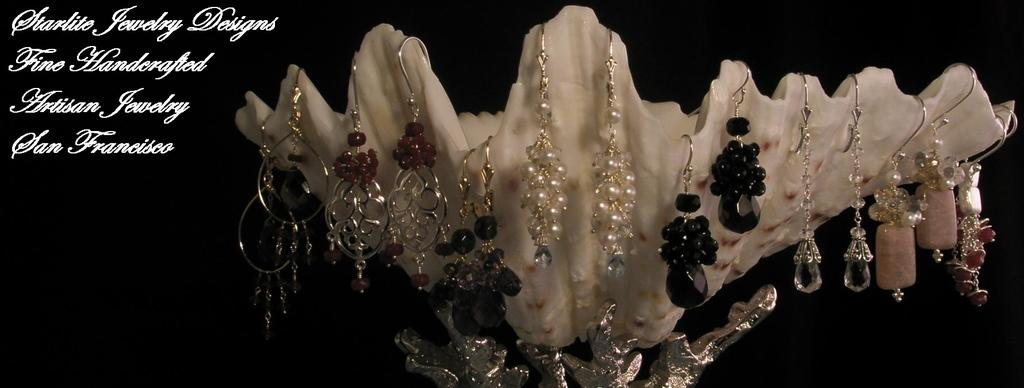What is hanging on the edges of the shell in the image? There are pairs of earrings hanging on the edges of a shell. What can be observed about the overall appearance of the image? The background of the image is dark. Are there any additional elements on the image besides the shell and earrings? Yes, there are words on the image. How many beans are visible in the image? There are no beans present in the image. What type of crow can be seen interacting with the shell in the image? There is no crow present in the image; it only features a shell with earrings and words. 